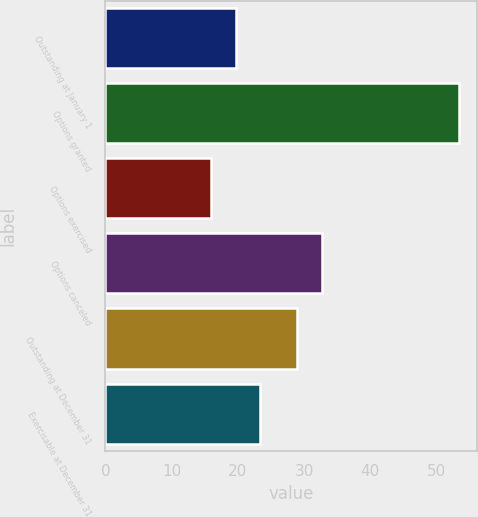Convert chart. <chart><loc_0><loc_0><loc_500><loc_500><bar_chart><fcel>Outstanding at January 1<fcel>Options granted<fcel>Options exercised<fcel>Options canceled<fcel>Outstanding at December 31<fcel>Exercisable at December 31<nl><fcel>19.67<fcel>53.44<fcel>15.92<fcel>32.68<fcel>28.93<fcel>23.42<nl></chart> 